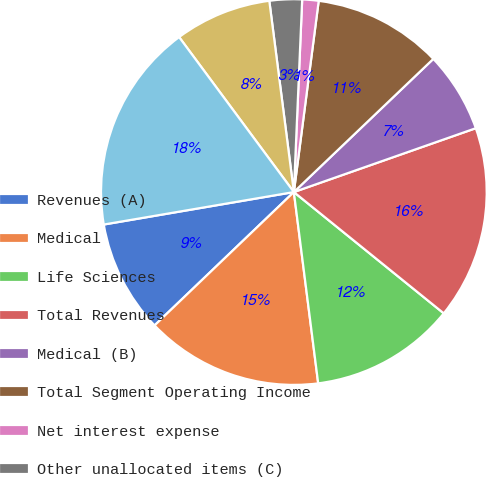Convert chart. <chart><loc_0><loc_0><loc_500><loc_500><pie_chart><fcel>Revenues (A)<fcel>Medical<fcel>Life Sciences<fcel>Total Revenues<fcel>Medical (B)<fcel>Total Segment Operating Income<fcel>Net interest expense<fcel>Other unallocated items (C)<fcel>Income Before Income Taxes<fcel>Total Segment Assets<nl><fcel>9.46%<fcel>14.86%<fcel>12.16%<fcel>16.2%<fcel>6.76%<fcel>10.81%<fcel>1.37%<fcel>2.72%<fcel>8.11%<fcel>17.55%<nl></chart> 